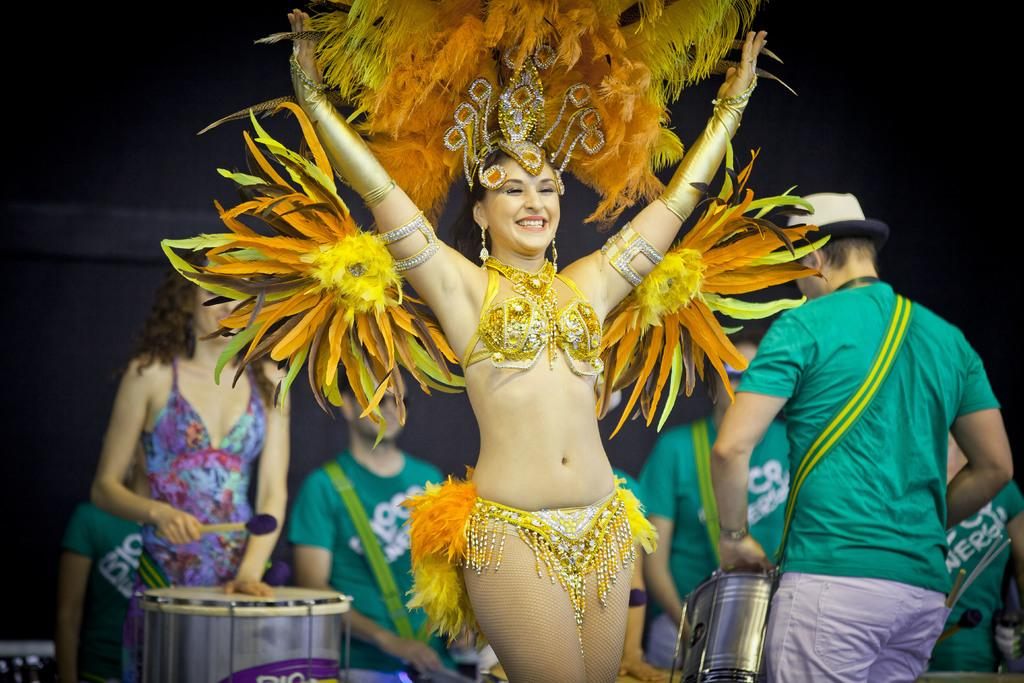Who is the main subject in the image? There is a girl in the center of the image. What is the girl wearing? The girl is wearing a costume. What are the people behind the girl doing? The people appear to be playing drums. What is the color of the background in the image? The background area is black. What type of waste can be seen in the image? There is no waste visible in the image. Is there a camera present in the image? There is no camera visible in the image. 